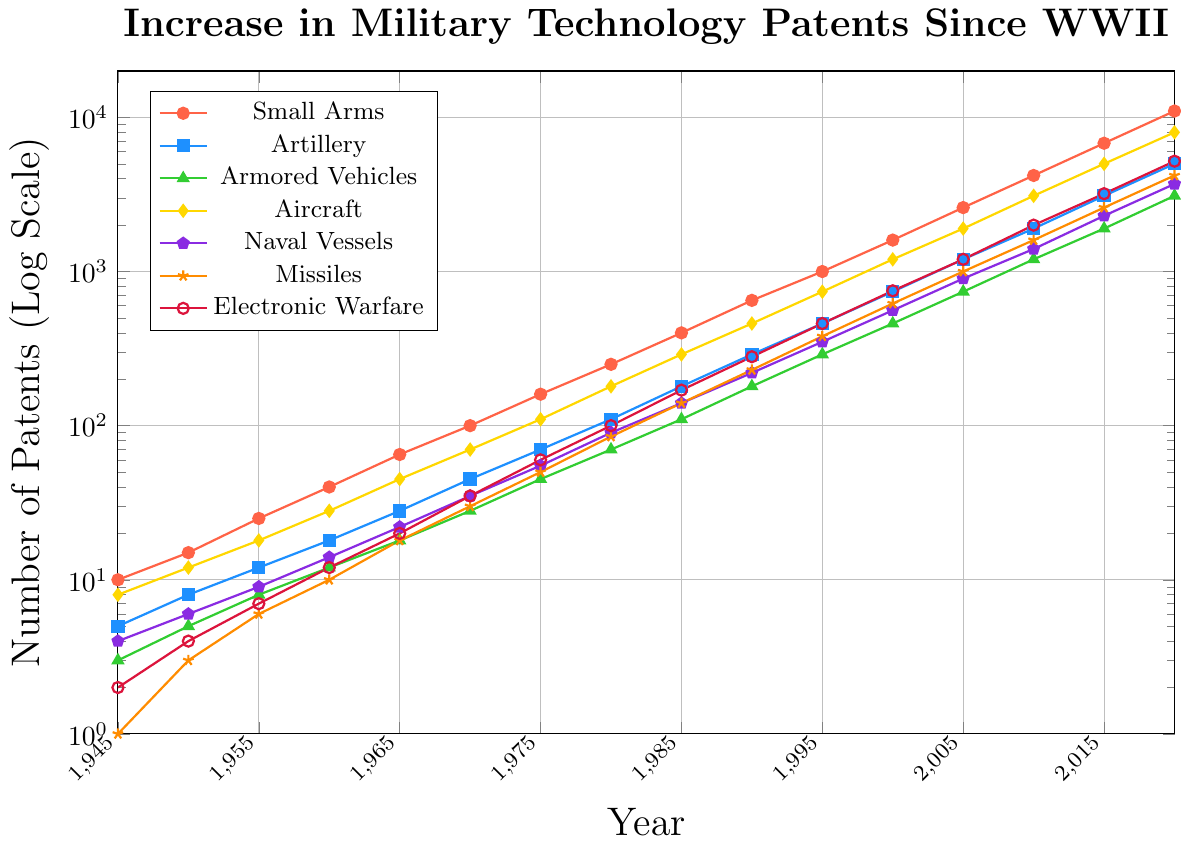How has the number of patents for small arms changed from 1945 to 2020? Looking at the small arms line, it starts at 10 patents in 1945 and increases to 11,000 patents by 2020.
Answer: The patents for small arms have increased substantially from 10 to 11,000 Which weapon type had the highest number of patents filed in 2020? Observing the legend, and matching the highest point in 2020 to its color, we can see that small arms, represented by red, had the highest number of patents at 11,000.
Answer: Small Arms How does the number of armored vehicle patents in 1955 compare to those in 1985? In 1955, there were 8 patents for armored vehicles. In 1985, this increased to 110 patents. This means the number of armored vehicle patents increased significantly from 1955 to 1985.
Answer: The number of patents increased from 8 to 110 Which weapon type had the smallest growth rate in patents from 1945 to 2020? Comparing the growth trends, missiles had the smallest starting count of 1 in 1945 but grew to 4,200 by 2020. The smallest overall initial count may imply lower annual growth but requires relative analysis.
Answer: Missiles Which year saw a notable spike in missile patents compared to previous years? By tracing the missile line (orange), between 1960 and 1965 there is a noticeable spike from 10 to 18, which indicates a significant jump.
Answer: 1965 What is the sum of the patents for aircraft and naval vessels in 1960? Aircraft patents in 1960 are 28, and naval vessels have 14 patents. Adding these two: 28 + 14 = 42.
Answer: The sum is 42 In which decade did electronic warfare patents surpass those for missiles? Comparing the trends for electronic warfare (crimson/red) and missiles (orange), the crossover happens around the 2000s.
Answer: Around 2000s How many more patents were filed for electronic warfare compared to artillery in 2020? In 2020, electronic warfare patents were 5,200 and artillery patents were 5,000. Subtracting these gives: 5,200 - 5,000 = 200.
Answer: There were 200 more patents for electronic warfare Is the trend for all weapon types increasing, and if so, at what rate? All weapon types show an increasing trend over the years. Calculating the rate for each may vary, but the usage of a log scale maintains visibility of exponential or linear growth visually.
Answer: Yes, at an increasing rate What is the average annual increase in missile patents from 2000 to 2020? In 2000 there were 620 missile patents, and in 2020 there were 4,200 patents. The difference over 20 years is 4,200 - 620 = 3,580. Dividing by 20 gives an average annual increase of 179 patents per year.
Answer: The average annual increase is 179 